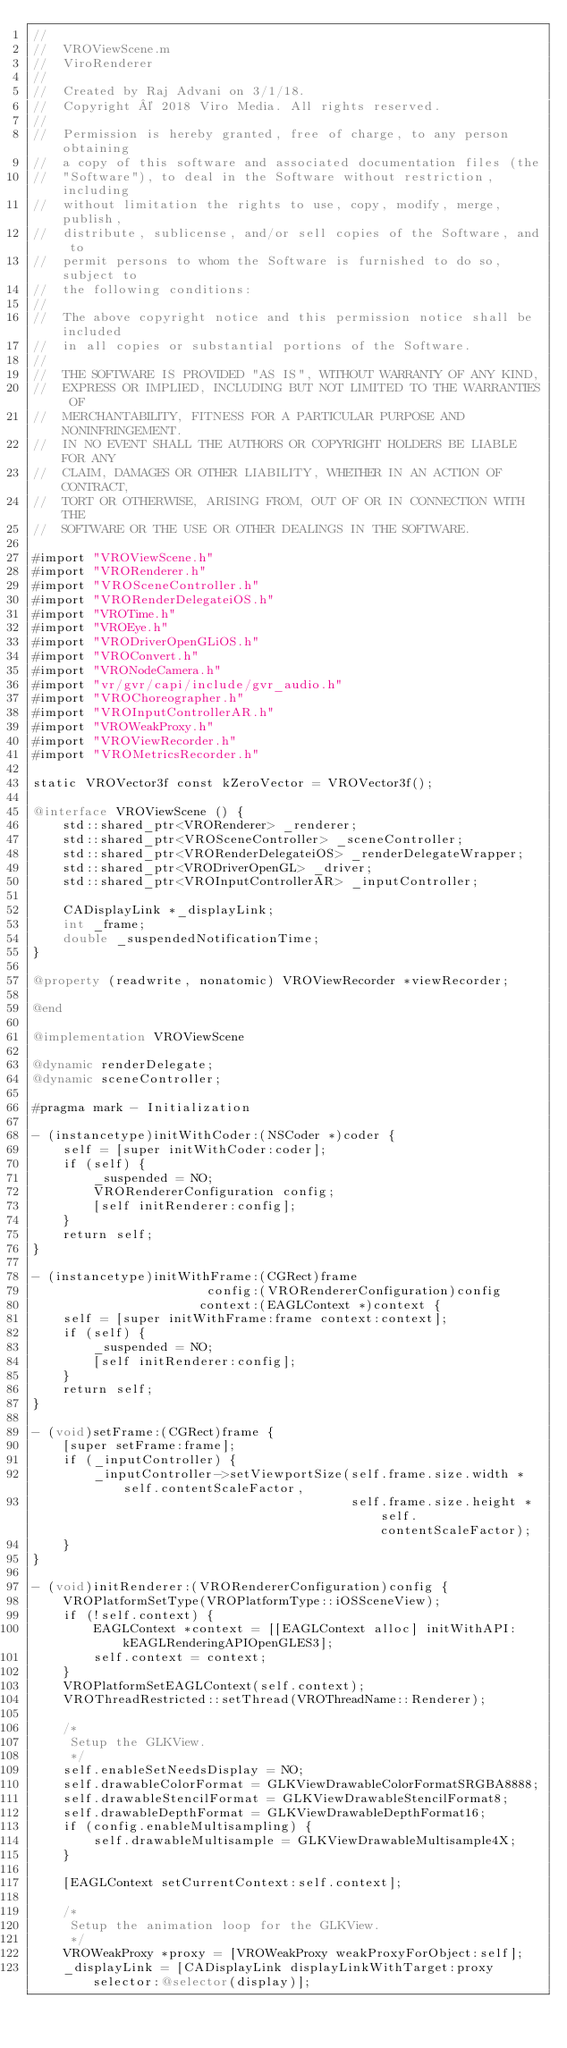<code> <loc_0><loc_0><loc_500><loc_500><_ObjectiveC_>//
//  VROViewScene.m
//  ViroRenderer
//
//  Created by Raj Advani on 3/1/18.
//  Copyright © 2018 Viro Media. All rights reserved.
//
//  Permission is hereby granted, free of charge, to any person obtaining
//  a copy of this software and associated documentation files (the
//  "Software"), to deal in the Software without restriction, including
//  without limitation the rights to use, copy, modify, merge, publish,
//  distribute, sublicense, and/or sell copies of the Software, and to
//  permit persons to whom the Software is furnished to do so, subject to
//  the following conditions:
//
//  The above copyright notice and this permission notice shall be included
//  in all copies or substantial portions of the Software.
//
//  THE SOFTWARE IS PROVIDED "AS IS", WITHOUT WARRANTY OF ANY KIND,
//  EXPRESS OR IMPLIED, INCLUDING BUT NOT LIMITED TO THE WARRANTIES OF
//  MERCHANTABILITY, FITNESS FOR A PARTICULAR PURPOSE AND NONINFRINGEMENT.
//  IN NO EVENT SHALL THE AUTHORS OR COPYRIGHT HOLDERS BE LIABLE FOR ANY
//  CLAIM, DAMAGES OR OTHER LIABILITY, WHETHER IN AN ACTION OF CONTRACT,
//  TORT OR OTHERWISE, ARISING FROM, OUT OF OR IN CONNECTION WITH THE
//  SOFTWARE OR THE USE OR OTHER DEALINGS IN THE SOFTWARE.

#import "VROViewScene.h"
#import "VRORenderer.h"
#import "VROSceneController.h"
#import "VRORenderDelegateiOS.h"
#import "VROTime.h"
#import "VROEye.h"
#import "VRODriverOpenGLiOS.h"
#import "VROConvert.h"
#import "VRONodeCamera.h"
#import "vr/gvr/capi/include/gvr_audio.h"
#import "VROChoreographer.h"
#import "VROInputControllerAR.h"
#import "VROWeakProxy.h"
#import "VROViewRecorder.h"
#import "VROMetricsRecorder.h"

static VROVector3f const kZeroVector = VROVector3f();

@interface VROViewScene () {
    std::shared_ptr<VRORenderer> _renderer;
    std::shared_ptr<VROSceneController> _sceneController;
    std::shared_ptr<VRORenderDelegateiOS> _renderDelegateWrapper;
    std::shared_ptr<VRODriverOpenGL> _driver;
    std::shared_ptr<VROInputControllerAR> _inputController;
    
    CADisplayLink *_displayLink;
    int _frame;
    double _suspendedNotificationTime;
}

@property (readwrite, nonatomic) VROViewRecorder *viewRecorder;

@end

@implementation VROViewScene

@dynamic renderDelegate;
@dynamic sceneController;

#pragma mark - Initialization

- (instancetype)initWithCoder:(NSCoder *)coder {
    self = [super initWithCoder:coder];
    if (self) {
        _suspended = NO;
        VRORendererConfiguration config;
        [self initRenderer:config];
    }
    return self;
}

- (instancetype)initWithFrame:(CGRect)frame
                       config:(VRORendererConfiguration)config
                      context:(EAGLContext *)context {
    self = [super initWithFrame:frame context:context];
    if (self) {
        _suspended = NO;
        [self initRenderer:config];
    }
    return self;
}

- (void)setFrame:(CGRect)frame {
    [super setFrame:frame];
    if (_inputController) {
        _inputController->setViewportSize(self.frame.size.width * self.contentScaleFactor,
                                          self.frame.size.height * self.contentScaleFactor);
    }
}

- (void)initRenderer:(VRORendererConfiguration)config {
    VROPlatformSetType(VROPlatformType::iOSSceneView);
    if (!self.context) {
        EAGLContext *context = [[EAGLContext alloc] initWithAPI:kEAGLRenderingAPIOpenGLES3];
        self.context = context;
    }
    VROPlatformSetEAGLContext(self.context);
    VROThreadRestricted::setThread(VROThreadName::Renderer);
    
    /*
     Setup the GLKView.
     */
    self.enableSetNeedsDisplay = NO;
    self.drawableColorFormat = GLKViewDrawableColorFormatSRGBA8888;
    self.drawableStencilFormat = GLKViewDrawableStencilFormat8;
    self.drawableDepthFormat = GLKViewDrawableDepthFormat16;
    if (config.enableMultisampling) {
        self.drawableMultisample = GLKViewDrawableMultisample4X;
    }
    
    [EAGLContext setCurrentContext:self.context];
    
    /*
     Setup the animation loop for the GLKView.
     */
    VROWeakProxy *proxy = [VROWeakProxy weakProxyForObject:self];
    _displayLink = [CADisplayLink displayLinkWithTarget:proxy selector:@selector(display)];</code> 